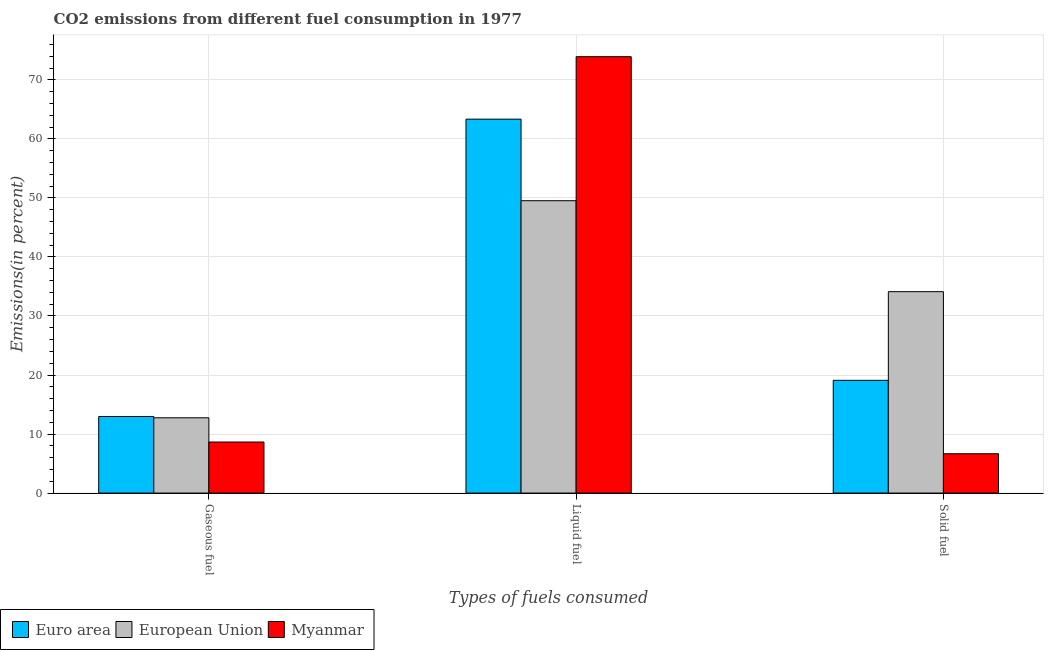How many different coloured bars are there?
Give a very brief answer. 3. How many groups of bars are there?
Your answer should be very brief. 3. Are the number of bars per tick equal to the number of legend labels?
Provide a succinct answer. Yes. Are the number of bars on each tick of the X-axis equal?
Your response must be concise. Yes. How many bars are there on the 1st tick from the left?
Give a very brief answer. 3. How many bars are there on the 3rd tick from the right?
Ensure brevity in your answer.  3. What is the label of the 1st group of bars from the left?
Offer a very short reply. Gaseous fuel. What is the percentage of solid fuel emission in Myanmar?
Ensure brevity in your answer.  6.66. Across all countries, what is the maximum percentage of liquid fuel emission?
Keep it short and to the point. 73.92. Across all countries, what is the minimum percentage of solid fuel emission?
Provide a short and direct response. 6.66. In which country was the percentage of liquid fuel emission maximum?
Give a very brief answer. Myanmar. In which country was the percentage of liquid fuel emission minimum?
Your answer should be very brief. European Union. What is the total percentage of liquid fuel emission in the graph?
Offer a terse response. 186.78. What is the difference between the percentage of solid fuel emission in European Union and that in Myanmar?
Your answer should be very brief. 27.46. What is the difference between the percentage of gaseous fuel emission in Euro area and the percentage of solid fuel emission in European Union?
Make the answer very short. -21.14. What is the average percentage of gaseous fuel emission per country?
Give a very brief answer. 11.46. What is the difference between the percentage of gaseous fuel emission and percentage of solid fuel emission in European Union?
Provide a short and direct response. -21.37. What is the ratio of the percentage of solid fuel emission in European Union to that in Myanmar?
Your response must be concise. 5.12. Is the percentage of gaseous fuel emission in Myanmar less than that in European Union?
Offer a terse response. Yes. What is the difference between the highest and the second highest percentage of liquid fuel emission?
Keep it short and to the point. 10.58. What is the difference between the highest and the lowest percentage of solid fuel emission?
Provide a short and direct response. 27.46. Is the sum of the percentage of solid fuel emission in European Union and Euro area greater than the maximum percentage of liquid fuel emission across all countries?
Make the answer very short. No. What does the 3rd bar from the left in Gaseous fuel represents?
Keep it short and to the point. Myanmar. What does the 2nd bar from the right in Solid fuel represents?
Provide a short and direct response. European Union. How many bars are there?
Your answer should be very brief. 9. How many countries are there in the graph?
Provide a short and direct response. 3. What is the difference between two consecutive major ticks on the Y-axis?
Offer a very short reply. 10. Does the graph contain any zero values?
Offer a terse response. No. Does the graph contain grids?
Your answer should be compact. Yes. How many legend labels are there?
Ensure brevity in your answer.  3. How are the legend labels stacked?
Make the answer very short. Horizontal. What is the title of the graph?
Provide a short and direct response. CO2 emissions from different fuel consumption in 1977. Does "Portugal" appear as one of the legend labels in the graph?
Provide a short and direct response. No. What is the label or title of the X-axis?
Your response must be concise. Types of fuels consumed. What is the label or title of the Y-axis?
Offer a terse response. Emissions(in percent). What is the Emissions(in percent) of Euro area in Gaseous fuel?
Offer a very short reply. 12.97. What is the Emissions(in percent) in European Union in Gaseous fuel?
Provide a succinct answer. 12.75. What is the Emissions(in percent) in Myanmar in Gaseous fuel?
Keep it short and to the point. 8.65. What is the Emissions(in percent) of Euro area in Liquid fuel?
Provide a succinct answer. 63.34. What is the Emissions(in percent) in European Union in Liquid fuel?
Your response must be concise. 49.52. What is the Emissions(in percent) in Myanmar in Liquid fuel?
Provide a succinct answer. 73.92. What is the Emissions(in percent) of Euro area in Solid fuel?
Keep it short and to the point. 19.1. What is the Emissions(in percent) of European Union in Solid fuel?
Ensure brevity in your answer.  34.12. What is the Emissions(in percent) of Myanmar in Solid fuel?
Offer a very short reply. 6.66. Across all Types of fuels consumed, what is the maximum Emissions(in percent) in Euro area?
Your response must be concise. 63.34. Across all Types of fuels consumed, what is the maximum Emissions(in percent) of European Union?
Provide a succinct answer. 49.52. Across all Types of fuels consumed, what is the maximum Emissions(in percent) in Myanmar?
Keep it short and to the point. 73.92. Across all Types of fuels consumed, what is the minimum Emissions(in percent) of Euro area?
Offer a very short reply. 12.97. Across all Types of fuels consumed, what is the minimum Emissions(in percent) of European Union?
Make the answer very short. 12.75. Across all Types of fuels consumed, what is the minimum Emissions(in percent) in Myanmar?
Offer a very short reply. 6.66. What is the total Emissions(in percent) in Euro area in the graph?
Ensure brevity in your answer.  95.41. What is the total Emissions(in percent) in European Union in the graph?
Make the answer very short. 96.39. What is the total Emissions(in percent) in Myanmar in the graph?
Offer a terse response. 89.23. What is the difference between the Emissions(in percent) of Euro area in Gaseous fuel and that in Liquid fuel?
Ensure brevity in your answer.  -50.37. What is the difference between the Emissions(in percent) of European Union in Gaseous fuel and that in Liquid fuel?
Your response must be concise. -36.77. What is the difference between the Emissions(in percent) in Myanmar in Gaseous fuel and that in Liquid fuel?
Offer a terse response. -65.27. What is the difference between the Emissions(in percent) of Euro area in Gaseous fuel and that in Solid fuel?
Keep it short and to the point. -6.13. What is the difference between the Emissions(in percent) of European Union in Gaseous fuel and that in Solid fuel?
Make the answer very short. -21.37. What is the difference between the Emissions(in percent) in Myanmar in Gaseous fuel and that in Solid fuel?
Keep it short and to the point. 1.98. What is the difference between the Emissions(in percent) of Euro area in Liquid fuel and that in Solid fuel?
Your answer should be compact. 44.24. What is the difference between the Emissions(in percent) of European Union in Liquid fuel and that in Solid fuel?
Your answer should be very brief. 15.41. What is the difference between the Emissions(in percent) in Myanmar in Liquid fuel and that in Solid fuel?
Provide a short and direct response. 67.26. What is the difference between the Emissions(in percent) in Euro area in Gaseous fuel and the Emissions(in percent) in European Union in Liquid fuel?
Your response must be concise. -36.55. What is the difference between the Emissions(in percent) in Euro area in Gaseous fuel and the Emissions(in percent) in Myanmar in Liquid fuel?
Provide a succinct answer. -60.95. What is the difference between the Emissions(in percent) in European Union in Gaseous fuel and the Emissions(in percent) in Myanmar in Liquid fuel?
Make the answer very short. -61.17. What is the difference between the Emissions(in percent) in Euro area in Gaseous fuel and the Emissions(in percent) in European Union in Solid fuel?
Ensure brevity in your answer.  -21.14. What is the difference between the Emissions(in percent) of Euro area in Gaseous fuel and the Emissions(in percent) of Myanmar in Solid fuel?
Keep it short and to the point. 6.31. What is the difference between the Emissions(in percent) of European Union in Gaseous fuel and the Emissions(in percent) of Myanmar in Solid fuel?
Offer a terse response. 6.09. What is the difference between the Emissions(in percent) of Euro area in Liquid fuel and the Emissions(in percent) of European Union in Solid fuel?
Keep it short and to the point. 29.22. What is the difference between the Emissions(in percent) of Euro area in Liquid fuel and the Emissions(in percent) of Myanmar in Solid fuel?
Ensure brevity in your answer.  56.68. What is the difference between the Emissions(in percent) of European Union in Liquid fuel and the Emissions(in percent) of Myanmar in Solid fuel?
Provide a short and direct response. 42.86. What is the average Emissions(in percent) of Euro area per Types of fuels consumed?
Offer a terse response. 31.8. What is the average Emissions(in percent) in European Union per Types of fuels consumed?
Your answer should be compact. 32.13. What is the average Emissions(in percent) in Myanmar per Types of fuels consumed?
Offer a very short reply. 29.74. What is the difference between the Emissions(in percent) in Euro area and Emissions(in percent) in European Union in Gaseous fuel?
Make the answer very short. 0.22. What is the difference between the Emissions(in percent) of Euro area and Emissions(in percent) of Myanmar in Gaseous fuel?
Your answer should be very brief. 4.33. What is the difference between the Emissions(in percent) in European Union and Emissions(in percent) in Myanmar in Gaseous fuel?
Your response must be concise. 4.11. What is the difference between the Emissions(in percent) of Euro area and Emissions(in percent) of European Union in Liquid fuel?
Ensure brevity in your answer.  13.82. What is the difference between the Emissions(in percent) of Euro area and Emissions(in percent) of Myanmar in Liquid fuel?
Make the answer very short. -10.58. What is the difference between the Emissions(in percent) in European Union and Emissions(in percent) in Myanmar in Liquid fuel?
Ensure brevity in your answer.  -24.4. What is the difference between the Emissions(in percent) in Euro area and Emissions(in percent) in European Union in Solid fuel?
Give a very brief answer. -15.02. What is the difference between the Emissions(in percent) of Euro area and Emissions(in percent) of Myanmar in Solid fuel?
Provide a succinct answer. 12.44. What is the difference between the Emissions(in percent) of European Union and Emissions(in percent) of Myanmar in Solid fuel?
Offer a very short reply. 27.46. What is the ratio of the Emissions(in percent) of Euro area in Gaseous fuel to that in Liquid fuel?
Offer a terse response. 0.2. What is the ratio of the Emissions(in percent) in European Union in Gaseous fuel to that in Liquid fuel?
Your answer should be very brief. 0.26. What is the ratio of the Emissions(in percent) of Myanmar in Gaseous fuel to that in Liquid fuel?
Provide a succinct answer. 0.12. What is the ratio of the Emissions(in percent) in Euro area in Gaseous fuel to that in Solid fuel?
Ensure brevity in your answer.  0.68. What is the ratio of the Emissions(in percent) of European Union in Gaseous fuel to that in Solid fuel?
Keep it short and to the point. 0.37. What is the ratio of the Emissions(in percent) of Myanmar in Gaseous fuel to that in Solid fuel?
Provide a succinct answer. 1.3. What is the ratio of the Emissions(in percent) in Euro area in Liquid fuel to that in Solid fuel?
Offer a terse response. 3.32. What is the ratio of the Emissions(in percent) of European Union in Liquid fuel to that in Solid fuel?
Offer a very short reply. 1.45. What is the ratio of the Emissions(in percent) in Myanmar in Liquid fuel to that in Solid fuel?
Your answer should be very brief. 11.1. What is the difference between the highest and the second highest Emissions(in percent) of Euro area?
Give a very brief answer. 44.24. What is the difference between the highest and the second highest Emissions(in percent) of European Union?
Make the answer very short. 15.41. What is the difference between the highest and the second highest Emissions(in percent) in Myanmar?
Offer a very short reply. 65.27. What is the difference between the highest and the lowest Emissions(in percent) of Euro area?
Provide a succinct answer. 50.37. What is the difference between the highest and the lowest Emissions(in percent) in European Union?
Give a very brief answer. 36.77. What is the difference between the highest and the lowest Emissions(in percent) in Myanmar?
Make the answer very short. 67.26. 